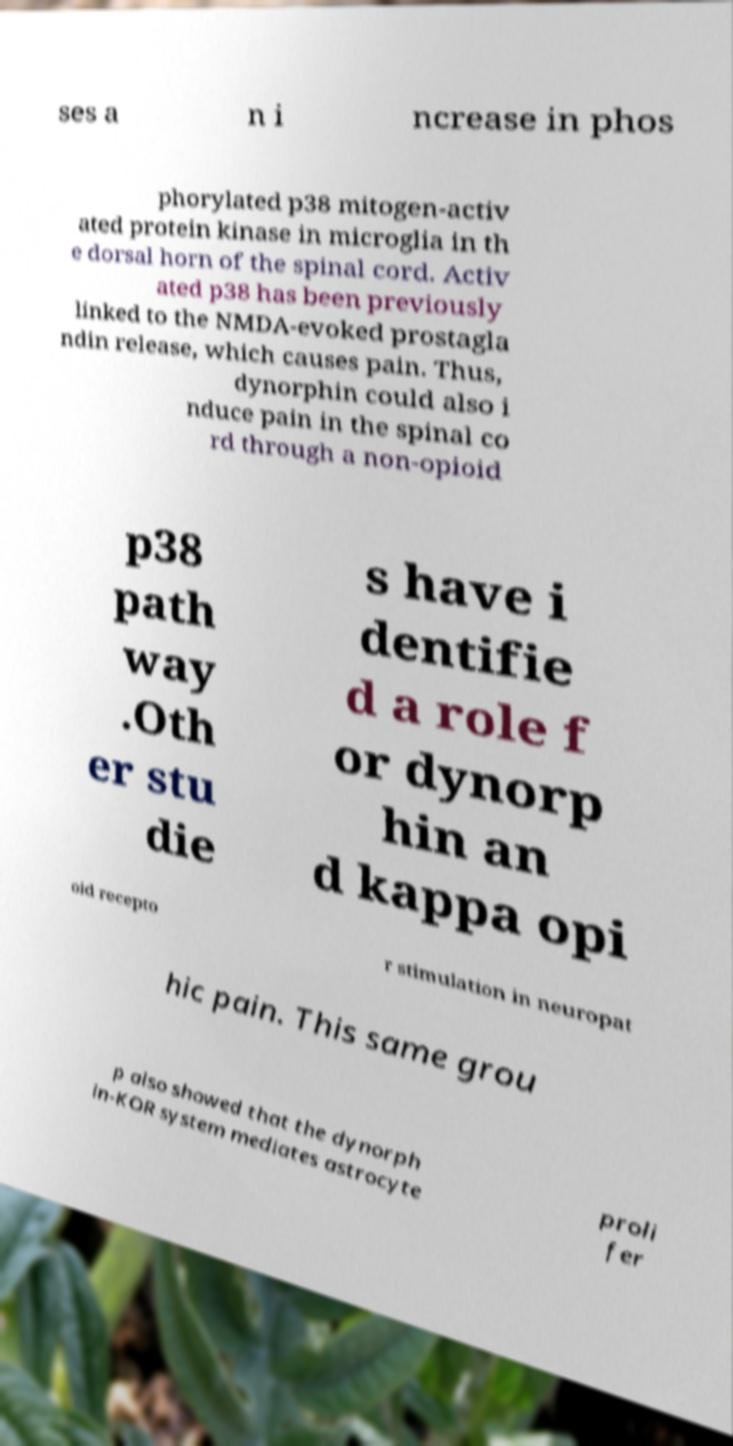There's text embedded in this image that I need extracted. Can you transcribe it verbatim? ses a n i ncrease in phos phorylated p38 mitogen-activ ated protein kinase in microglia in th e dorsal horn of the spinal cord. Activ ated p38 has been previously linked to the NMDA-evoked prostagla ndin release, which causes pain. Thus, dynorphin could also i nduce pain in the spinal co rd through a non-opioid p38 path way .Oth er stu die s have i dentifie d a role f or dynorp hin an d kappa opi oid recepto r stimulation in neuropat hic pain. This same grou p also showed that the dynorph in-KOR system mediates astrocyte proli fer 